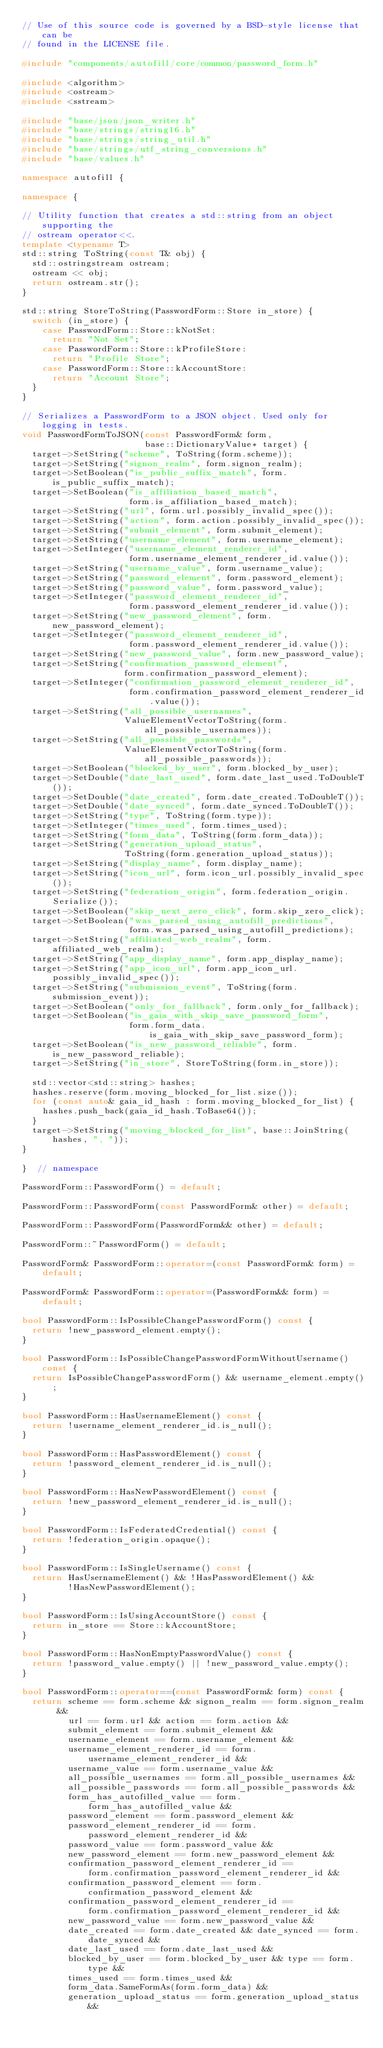Convert code to text. <code><loc_0><loc_0><loc_500><loc_500><_C++_>// Use of this source code is governed by a BSD-style license that can be
// found in the LICENSE file.

#include "components/autofill/core/common/password_form.h"

#include <algorithm>
#include <ostream>
#include <sstream>

#include "base/json/json_writer.h"
#include "base/strings/string16.h"
#include "base/strings/string_util.h"
#include "base/strings/utf_string_conversions.h"
#include "base/values.h"

namespace autofill {

namespace {

// Utility function that creates a std::string from an object supporting the
// ostream operator<<.
template <typename T>
std::string ToString(const T& obj) {
  std::ostringstream ostream;
  ostream << obj;
  return ostream.str();
}

std::string StoreToString(PasswordForm::Store in_store) {
  switch (in_store) {
    case PasswordForm::Store::kNotSet:
      return "Not Set";
    case PasswordForm::Store::kProfileStore:
      return "Profile Store";
    case PasswordForm::Store::kAccountStore:
      return "Account Store";
  }
}

// Serializes a PasswordForm to a JSON object. Used only for logging in tests.
void PasswordFormToJSON(const PasswordForm& form,
                        base::DictionaryValue* target) {
  target->SetString("scheme", ToString(form.scheme));
  target->SetString("signon_realm", form.signon_realm);
  target->SetBoolean("is_public_suffix_match", form.is_public_suffix_match);
  target->SetBoolean("is_affiliation_based_match",
                     form.is_affiliation_based_match);
  target->SetString("url", form.url.possibly_invalid_spec());
  target->SetString("action", form.action.possibly_invalid_spec());
  target->SetString("submit_element", form.submit_element);
  target->SetString("username_element", form.username_element);
  target->SetInteger("username_element_renderer_id",
                     form.username_element_renderer_id.value());
  target->SetString("username_value", form.username_value);
  target->SetString("password_element", form.password_element);
  target->SetString("password_value", form.password_value);
  target->SetInteger("password_element_renderer_id",
                     form.password_element_renderer_id.value());
  target->SetString("new_password_element", form.new_password_element);
  target->SetInteger("password_element_renderer_id",
                     form.password_element_renderer_id.value());
  target->SetString("new_password_value", form.new_password_value);
  target->SetString("confirmation_password_element",
                    form.confirmation_password_element);
  target->SetInteger("confirmation_password_element_renderer_id",
                     form.confirmation_password_element_renderer_id.value());
  target->SetString("all_possible_usernames",
                    ValueElementVectorToString(form.all_possible_usernames));
  target->SetString("all_possible_passwords",
                    ValueElementVectorToString(form.all_possible_passwords));
  target->SetBoolean("blocked_by_user", form.blocked_by_user);
  target->SetDouble("date_last_used", form.date_last_used.ToDoubleT());
  target->SetDouble("date_created", form.date_created.ToDoubleT());
  target->SetDouble("date_synced", form.date_synced.ToDoubleT());
  target->SetString("type", ToString(form.type));
  target->SetInteger("times_used", form.times_used);
  target->SetString("form_data", ToString(form.form_data));
  target->SetString("generation_upload_status",
                    ToString(form.generation_upload_status));
  target->SetString("display_name", form.display_name);
  target->SetString("icon_url", form.icon_url.possibly_invalid_spec());
  target->SetString("federation_origin", form.federation_origin.Serialize());
  target->SetBoolean("skip_next_zero_click", form.skip_zero_click);
  target->SetBoolean("was_parsed_using_autofill_predictions",
                     form.was_parsed_using_autofill_predictions);
  target->SetString("affiliated_web_realm", form.affiliated_web_realm);
  target->SetString("app_display_name", form.app_display_name);
  target->SetString("app_icon_url", form.app_icon_url.possibly_invalid_spec());
  target->SetString("submission_event", ToString(form.submission_event));
  target->SetBoolean("only_for_fallback", form.only_for_fallback);
  target->SetBoolean("is_gaia_with_skip_save_password_form",
                     form.form_data.is_gaia_with_skip_save_password_form);
  target->SetBoolean("is_new_password_reliable", form.is_new_password_reliable);
  target->SetString("in_store", StoreToString(form.in_store));

  std::vector<std::string> hashes;
  hashes.reserve(form.moving_blocked_for_list.size());
  for (const auto& gaia_id_hash : form.moving_blocked_for_list) {
    hashes.push_back(gaia_id_hash.ToBase64());
  }
  target->SetString("moving_blocked_for_list", base::JoinString(hashes, ", "));
}

}  // namespace

PasswordForm::PasswordForm() = default;

PasswordForm::PasswordForm(const PasswordForm& other) = default;

PasswordForm::PasswordForm(PasswordForm&& other) = default;

PasswordForm::~PasswordForm() = default;

PasswordForm& PasswordForm::operator=(const PasswordForm& form) = default;

PasswordForm& PasswordForm::operator=(PasswordForm&& form) = default;

bool PasswordForm::IsPossibleChangePasswordForm() const {
  return !new_password_element.empty();
}

bool PasswordForm::IsPossibleChangePasswordFormWithoutUsername() const {
  return IsPossibleChangePasswordForm() && username_element.empty();
}

bool PasswordForm::HasUsernameElement() const {
  return !username_element_renderer_id.is_null();
}

bool PasswordForm::HasPasswordElement() const {
  return !password_element_renderer_id.is_null();
}

bool PasswordForm::HasNewPasswordElement() const {
  return !new_password_element_renderer_id.is_null();
}

bool PasswordForm::IsFederatedCredential() const {
  return !federation_origin.opaque();
}

bool PasswordForm::IsSingleUsername() const {
  return HasUsernameElement() && !HasPasswordElement() &&
         !HasNewPasswordElement();
}

bool PasswordForm::IsUsingAccountStore() const {
  return in_store == Store::kAccountStore;
}

bool PasswordForm::HasNonEmptyPasswordValue() const {
  return !password_value.empty() || !new_password_value.empty();
}

bool PasswordForm::operator==(const PasswordForm& form) const {
  return scheme == form.scheme && signon_realm == form.signon_realm &&
         url == form.url && action == form.action &&
         submit_element == form.submit_element &&
         username_element == form.username_element &&
         username_element_renderer_id == form.username_element_renderer_id &&
         username_value == form.username_value &&
         all_possible_usernames == form.all_possible_usernames &&
         all_possible_passwords == form.all_possible_passwords &&
         form_has_autofilled_value == form.form_has_autofilled_value &&
         password_element == form.password_element &&
         password_element_renderer_id == form.password_element_renderer_id &&
         password_value == form.password_value &&
         new_password_element == form.new_password_element &&
         confirmation_password_element_renderer_id ==
             form.confirmation_password_element_renderer_id &&
         confirmation_password_element == form.confirmation_password_element &&
         confirmation_password_element_renderer_id ==
             form.confirmation_password_element_renderer_id &&
         new_password_value == form.new_password_value &&
         date_created == form.date_created && date_synced == form.date_synced &&
         date_last_used == form.date_last_used &&
         blocked_by_user == form.blocked_by_user && type == form.type &&
         times_used == form.times_used &&
         form_data.SameFormAs(form.form_data) &&
         generation_upload_status == form.generation_upload_status &&</code> 